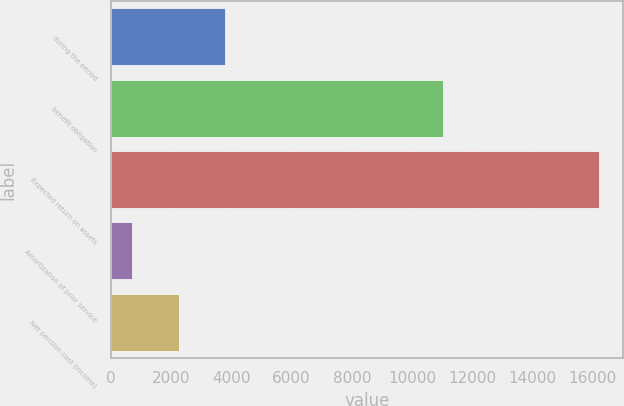<chart> <loc_0><loc_0><loc_500><loc_500><bar_chart><fcel>during the period<fcel>benefit obligation<fcel>Expected return on assets<fcel>Amortization of prior service<fcel>Net pension cost (income)<nl><fcel>3803.4<fcel>11013<fcel>16197<fcel>705<fcel>2254.2<nl></chart> 